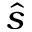Convert formula to latex. <formula><loc_0><loc_0><loc_500><loc_500>\hat { s }</formula> 